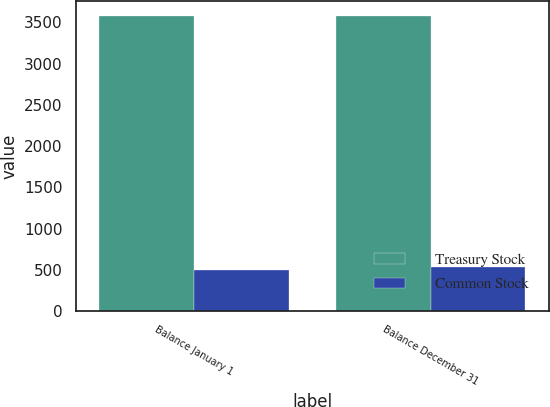<chart> <loc_0><loc_0><loc_500><loc_500><stacked_bar_chart><ecel><fcel>Balance January 1<fcel>Balance December 31<nl><fcel>Treasury Stock<fcel>3577<fcel>3577<nl><fcel>Common Stock<fcel>495<fcel>536<nl></chart> 